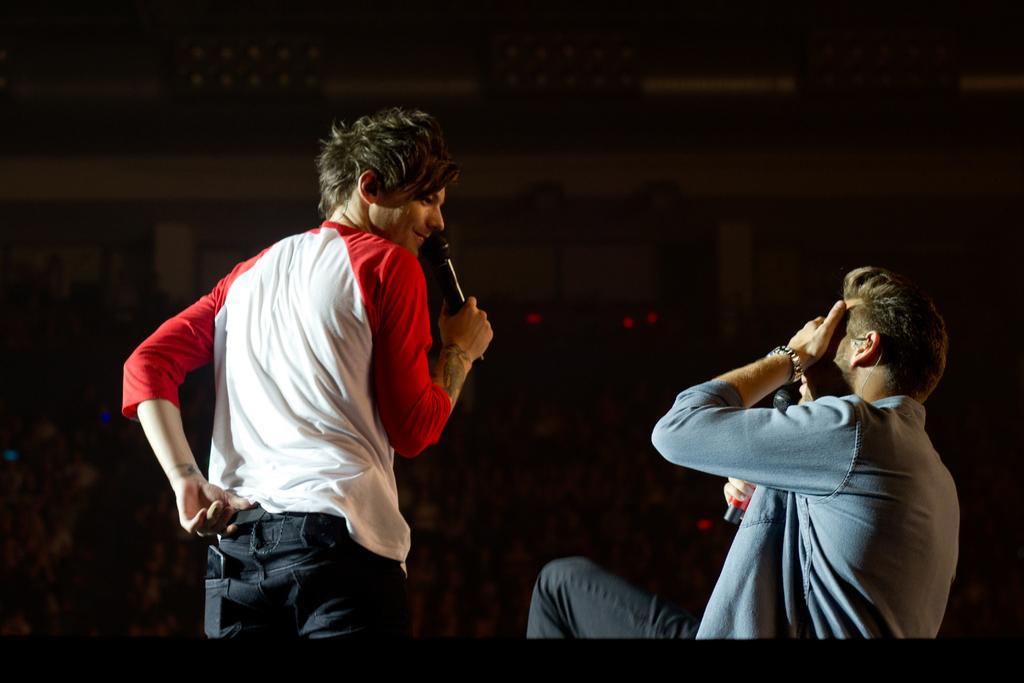How would you summarize this image in a sentence or two? In this image, I can see two persons holding mike's. There is a dark background. 